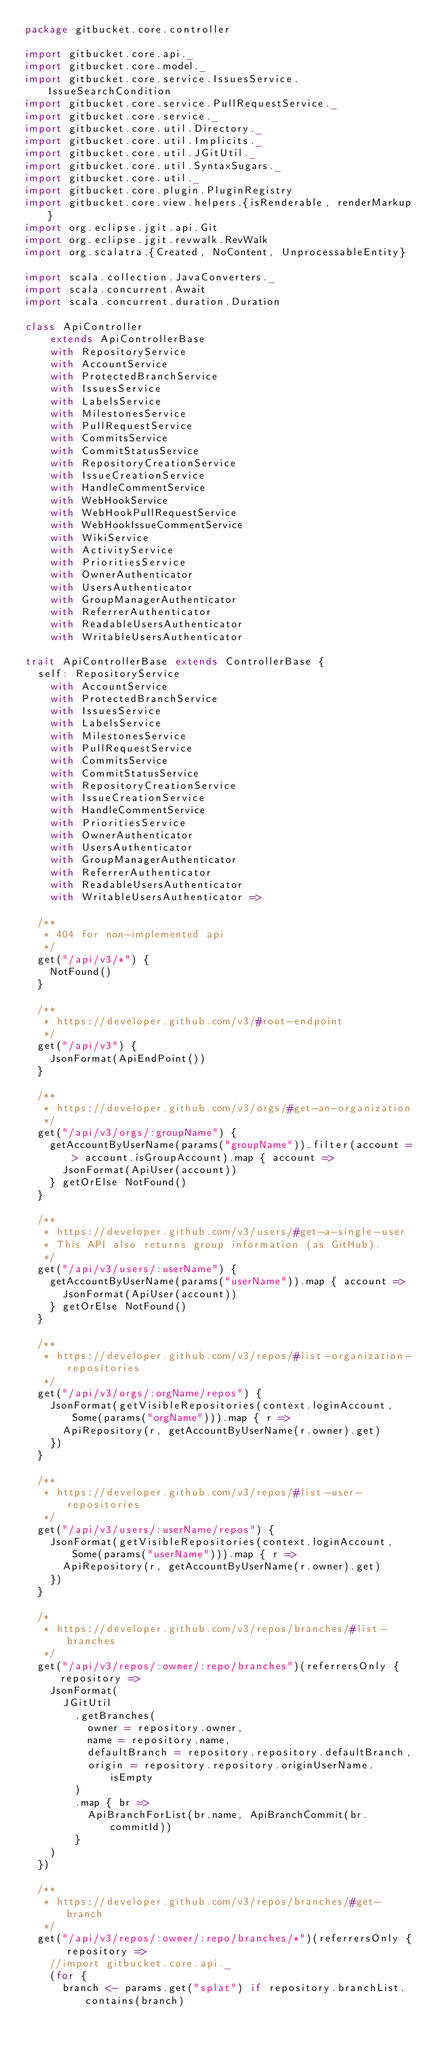<code> <loc_0><loc_0><loc_500><loc_500><_Scala_>package gitbucket.core.controller

import gitbucket.core.api._
import gitbucket.core.model._
import gitbucket.core.service.IssuesService.IssueSearchCondition
import gitbucket.core.service.PullRequestService._
import gitbucket.core.service._
import gitbucket.core.util.Directory._
import gitbucket.core.util.Implicits._
import gitbucket.core.util.JGitUtil._
import gitbucket.core.util.SyntaxSugars._
import gitbucket.core.util._
import gitbucket.core.plugin.PluginRegistry
import gitbucket.core.view.helpers.{isRenderable, renderMarkup}
import org.eclipse.jgit.api.Git
import org.eclipse.jgit.revwalk.RevWalk
import org.scalatra.{Created, NoContent, UnprocessableEntity}

import scala.collection.JavaConverters._
import scala.concurrent.Await
import scala.concurrent.duration.Duration

class ApiController
    extends ApiControllerBase
    with RepositoryService
    with AccountService
    with ProtectedBranchService
    with IssuesService
    with LabelsService
    with MilestonesService
    with PullRequestService
    with CommitsService
    with CommitStatusService
    with RepositoryCreationService
    with IssueCreationService
    with HandleCommentService
    with WebHookService
    with WebHookPullRequestService
    with WebHookIssueCommentService
    with WikiService
    with ActivityService
    with PrioritiesService
    with OwnerAuthenticator
    with UsersAuthenticator
    with GroupManagerAuthenticator
    with ReferrerAuthenticator
    with ReadableUsersAuthenticator
    with WritableUsersAuthenticator

trait ApiControllerBase extends ControllerBase {
  self: RepositoryService
    with AccountService
    with ProtectedBranchService
    with IssuesService
    with LabelsService
    with MilestonesService
    with PullRequestService
    with CommitsService
    with CommitStatusService
    with RepositoryCreationService
    with IssueCreationService
    with HandleCommentService
    with PrioritiesService
    with OwnerAuthenticator
    with UsersAuthenticator
    with GroupManagerAuthenticator
    with ReferrerAuthenticator
    with ReadableUsersAuthenticator
    with WritableUsersAuthenticator =>

  /**
   * 404 for non-implemented api
   */
  get("/api/v3/*") {
    NotFound()
  }

  /**
   * https://developer.github.com/v3/#root-endpoint
   */
  get("/api/v3") {
    JsonFormat(ApiEndPoint())
  }

  /**
   * https://developer.github.com/v3/orgs/#get-an-organization
   */
  get("/api/v3/orgs/:groupName") {
    getAccountByUserName(params("groupName")).filter(account => account.isGroupAccount).map { account =>
      JsonFormat(ApiUser(account))
    } getOrElse NotFound()
  }

  /**
   * https://developer.github.com/v3/users/#get-a-single-user
   * This API also returns group information (as GitHub).
   */
  get("/api/v3/users/:userName") {
    getAccountByUserName(params("userName")).map { account =>
      JsonFormat(ApiUser(account))
    } getOrElse NotFound()
  }

  /**
   * https://developer.github.com/v3/repos/#list-organization-repositories
   */
  get("/api/v3/orgs/:orgName/repos") {
    JsonFormat(getVisibleRepositories(context.loginAccount, Some(params("orgName"))).map { r =>
      ApiRepository(r, getAccountByUserName(r.owner).get)
    })
  }

  /**
   * https://developer.github.com/v3/repos/#list-user-repositories
   */
  get("/api/v3/users/:userName/repos") {
    JsonFormat(getVisibleRepositories(context.loginAccount, Some(params("userName"))).map { r =>
      ApiRepository(r, getAccountByUserName(r.owner).get)
    })
  }

  /*
   * https://developer.github.com/v3/repos/branches/#list-branches
   */
  get("/api/v3/repos/:owner/:repo/branches")(referrersOnly { repository =>
    JsonFormat(
      JGitUtil
        .getBranches(
          owner = repository.owner,
          name = repository.name,
          defaultBranch = repository.repository.defaultBranch,
          origin = repository.repository.originUserName.isEmpty
        )
        .map { br =>
          ApiBranchForList(br.name, ApiBranchCommit(br.commitId))
        }
    )
  })

  /**
   * https://developer.github.com/v3/repos/branches/#get-branch
   */
  get("/api/v3/repos/:owner/:repo/branches/*")(referrersOnly { repository =>
    //import gitbucket.core.api._
    (for {
      branch <- params.get("splat") if repository.branchList.contains(branch)</code> 